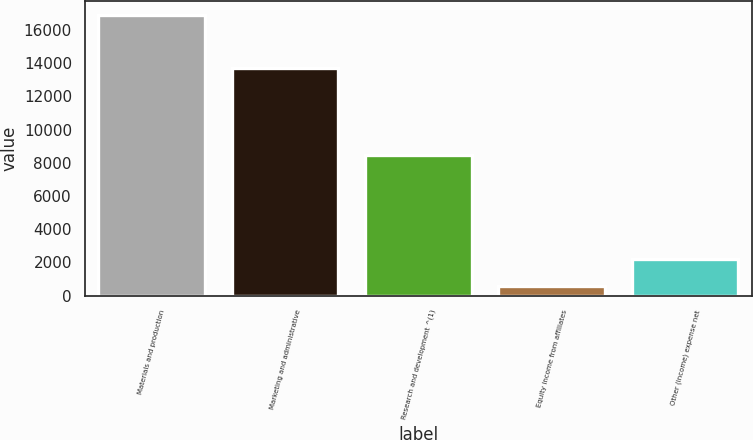Convert chart. <chart><loc_0><loc_0><loc_500><loc_500><bar_chart><fcel>Materials and production<fcel>Marketing and administrative<fcel>Research and development ^(1)<fcel>Equity income from affiliates<fcel>Other (income) expense net<nl><fcel>16871<fcel>13733<fcel>8467<fcel>610<fcel>2236.1<nl></chart> 